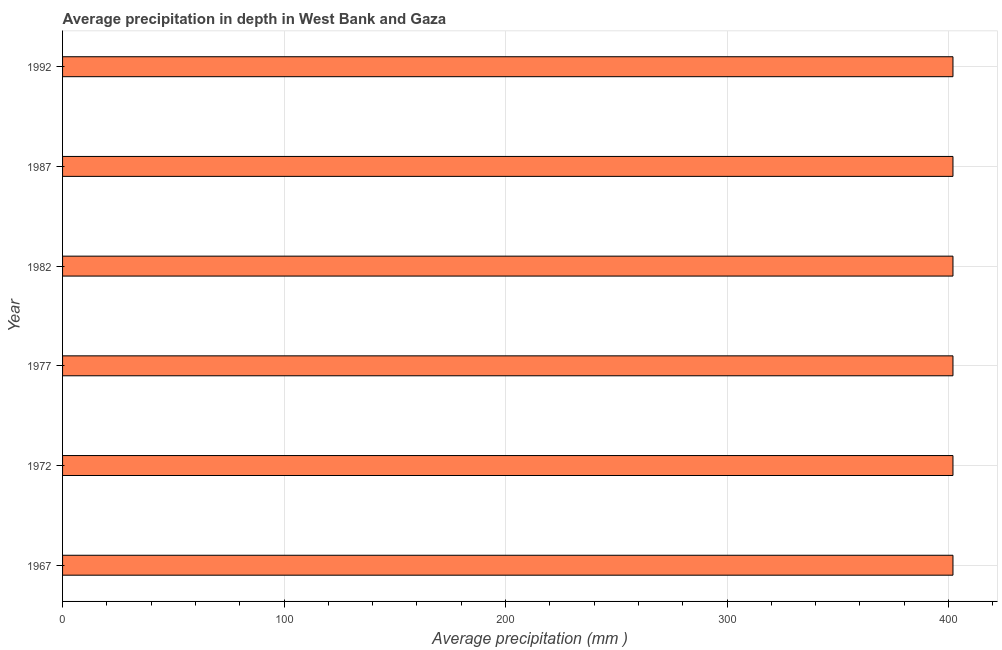Does the graph contain grids?
Ensure brevity in your answer.  Yes. What is the title of the graph?
Your answer should be compact. Average precipitation in depth in West Bank and Gaza. What is the label or title of the X-axis?
Offer a terse response. Average precipitation (mm ). What is the label or title of the Y-axis?
Your answer should be compact. Year. What is the average precipitation in depth in 1982?
Provide a succinct answer. 402. Across all years, what is the maximum average precipitation in depth?
Offer a very short reply. 402. Across all years, what is the minimum average precipitation in depth?
Your answer should be very brief. 402. In which year was the average precipitation in depth maximum?
Offer a terse response. 1967. In which year was the average precipitation in depth minimum?
Offer a terse response. 1967. What is the sum of the average precipitation in depth?
Make the answer very short. 2412. What is the average average precipitation in depth per year?
Ensure brevity in your answer.  402. What is the median average precipitation in depth?
Your response must be concise. 402. What is the ratio of the average precipitation in depth in 1967 to that in 1987?
Give a very brief answer. 1. Is the average precipitation in depth in 1967 less than that in 1977?
Offer a very short reply. No. Is the difference between the average precipitation in depth in 1972 and 1992 greater than the difference between any two years?
Offer a terse response. Yes. What is the difference between the highest and the second highest average precipitation in depth?
Offer a terse response. 0. In how many years, is the average precipitation in depth greater than the average average precipitation in depth taken over all years?
Provide a short and direct response. 0. What is the difference between two consecutive major ticks on the X-axis?
Your answer should be compact. 100. Are the values on the major ticks of X-axis written in scientific E-notation?
Keep it short and to the point. No. What is the Average precipitation (mm ) of 1967?
Offer a terse response. 402. What is the Average precipitation (mm ) of 1972?
Provide a succinct answer. 402. What is the Average precipitation (mm ) of 1977?
Make the answer very short. 402. What is the Average precipitation (mm ) of 1982?
Provide a short and direct response. 402. What is the Average precipitation (mm ) of 1987?
Offer a very short reply. 402. What is the Average precipitation (mm ) of 1992?
Make the answer very short. 402. What is the difference between the Average precipitation (mm ) in 1967 and 1977?
Your answer should be very brief. 0. What is the difference between the Average precipitation (mm ) in 1967 and 1992?
Your answer should be compact. 0. What is the difference between the Average precipitation (mm ) in 1972 and 1987?
Offer a very short reply. 0. What is the difference between the Average precipitation (mm ) in 1977 and 1982?
Provide a succinct answer. 0. What is the difference between the Average precipitation (mm ) in 1977 and 1987?
Your answer should be compact. 0. What is the difference between the Average precipitation (mm ) in 1982 and 1987?
Keep it short and to the point. 0. What is the difference between the Average precipitation (mm ) in 1982 and 1992?
Provide a short and direct response. 0. What is the difference between the Average precipitation (mm ) in 1987 and 1992?
Your answer should be very brief. 0. What is the ratio of the Average precipitation (mm ) in 1967 to that in 1977?
Your response must be concise. 1. What is the ratio of the Average precipitation (mm ) in 1967 to that in 1987?
Offer a very short reply. 1. What is the ratio of the Average precipitation (mm ) in 1972 to that in 1982?
Provide a short and direct response. 1. What is the ratio of the Average precipitation (mm ) in 1972 to that in 1987?
Make the answer very short. 1. What is the ratio of the Average precipitation (mm ) in 1972 to that in 1992?
Provide a succinct answer. 1. What is the ratio of the Average precipitation (mm ) in 1977 to that in 1982?
Provide a short and direct response. 1. What is the ratio of the Average precipitation (mm ) in 1977 to that in 1992?
Give a very brief answer. 1. What is the ratio of the Average precipitation (mm ) in 1987 to that in 1992?
Offer a terse response. 1. 